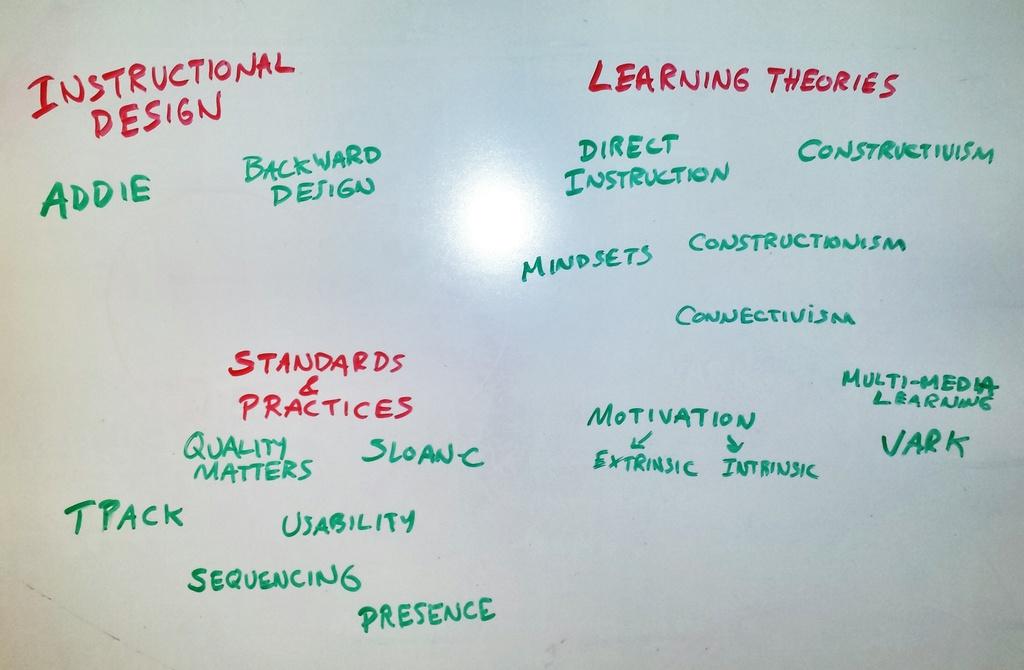What kind of design is mentioned in the top left corner?
Provide a short and direct response. Instructional. What's the topic of the right section?
Your response must be concise. Learning theories. 